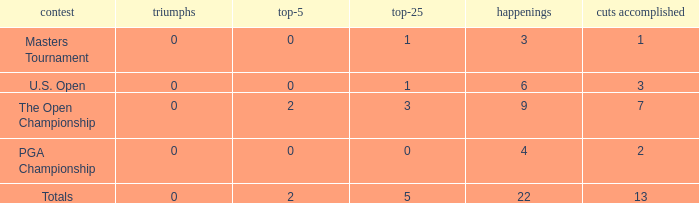What is the fewest number of top-25s for events with more than 13 cuts made? None. 